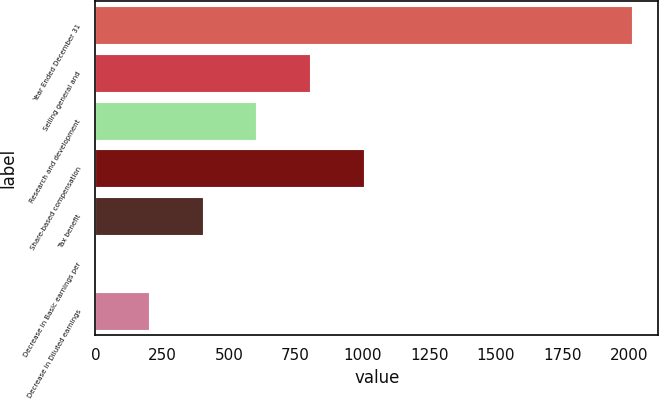Convert chart. <chart><loc_0><loc_0><loc_500><loc_500><bar_chart><fcel>Year Ended December 31<fcel>Selling general and<fcel>Research and development<fcel>Share-based compensation<fcel>Tax benefit<fcel>Decrease in Basic earnings per<fcel>Decrease in Diluted earnings<nl><fcel>2008<fcel>803.25<fcel>602.46<fcel>1004.04<fcel>401.67<fcel>0.09<fcel>200.88<nl></chart> 